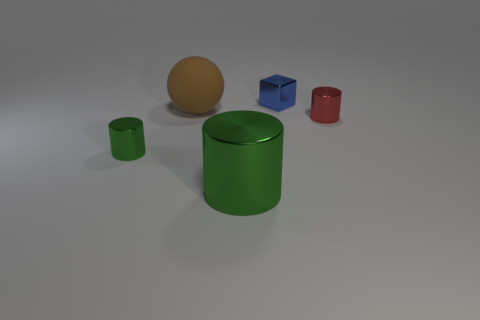How does the lighting in the image affect the appearance of materials? The direction and softness of the light create subtle highlights and shadows that accentuate the reflective properties of some objects, like the shiny blue cube and the green cylinder, while emphasizing the matte texture of the brown sphere. 